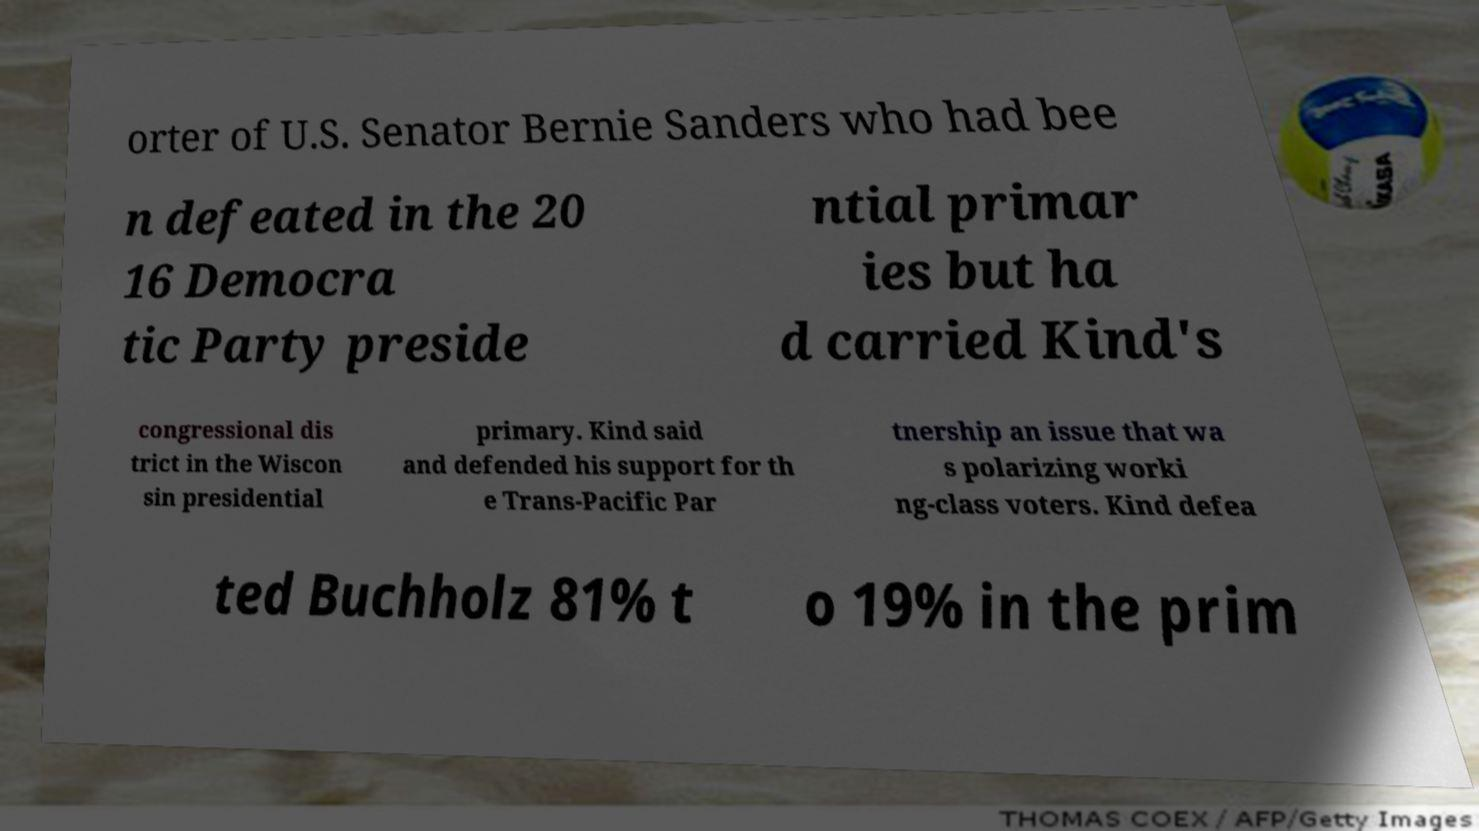There's text embedded in this image that I need extracted. Can you transcribe it verbatim? orter of U.S. Senator Bernie Sanders who had bee n defeated in the 20 16 Democra tic Party preside ntial primar ies but ha d carried Kind's congressional dis trict in the Wiscon sin presidential primary. Kind said and defended his support for th e Trans-Pacific Par tnership an issue that wa s polarizing worki ng-class voters. Kind defea ted Buchholz 81% t o 19% in the prim 